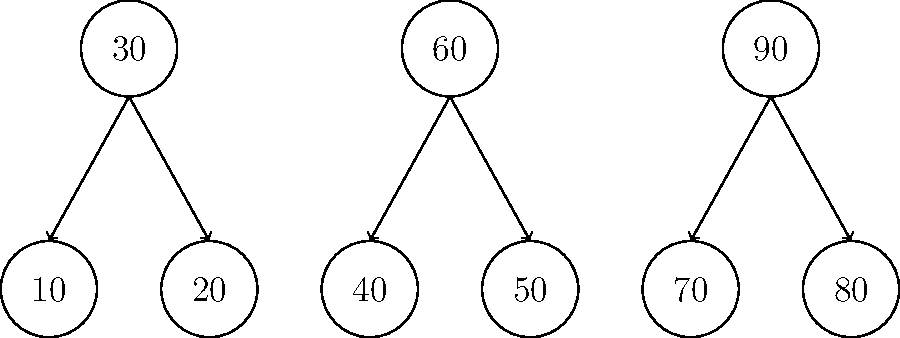Given the B-tree structure diagram above, what would be the most efficient path to search for the key 55 in this database index? Describe the traversal steps. To find the most efficient path to search for the key 55 in this B-tree index, we need to follow these steps:

1. Start at the root node (top level) of the B-tree.
2. Compare 55 with the keys in the root node:
   - 55 > 30
   - 55 < 60
3. Since 55 is between 30 and 60, we follow the pointer to the middle child node.
4. In the middle child node, we compare 55 with the keys:
   - 55 > 40
   - 55 > 50
5. Since 55 is greater than both 40 and 50, we would follow the pointer to the right of 50.
6. However, there is no child node to the right of 50 in this diagram.

Therefore, the search would conclude that the key 55 is not present in this B-tree index. The most efficient path to reach this conclusion is:

Root (30, 60, 90) → Middle child (40, 50)

This path minimizes the number of comparisons and node accesses, which is crucial for efficient database indexing and querying.
Answer: Root (30, 60, 90) → Middle child (40, 50) 